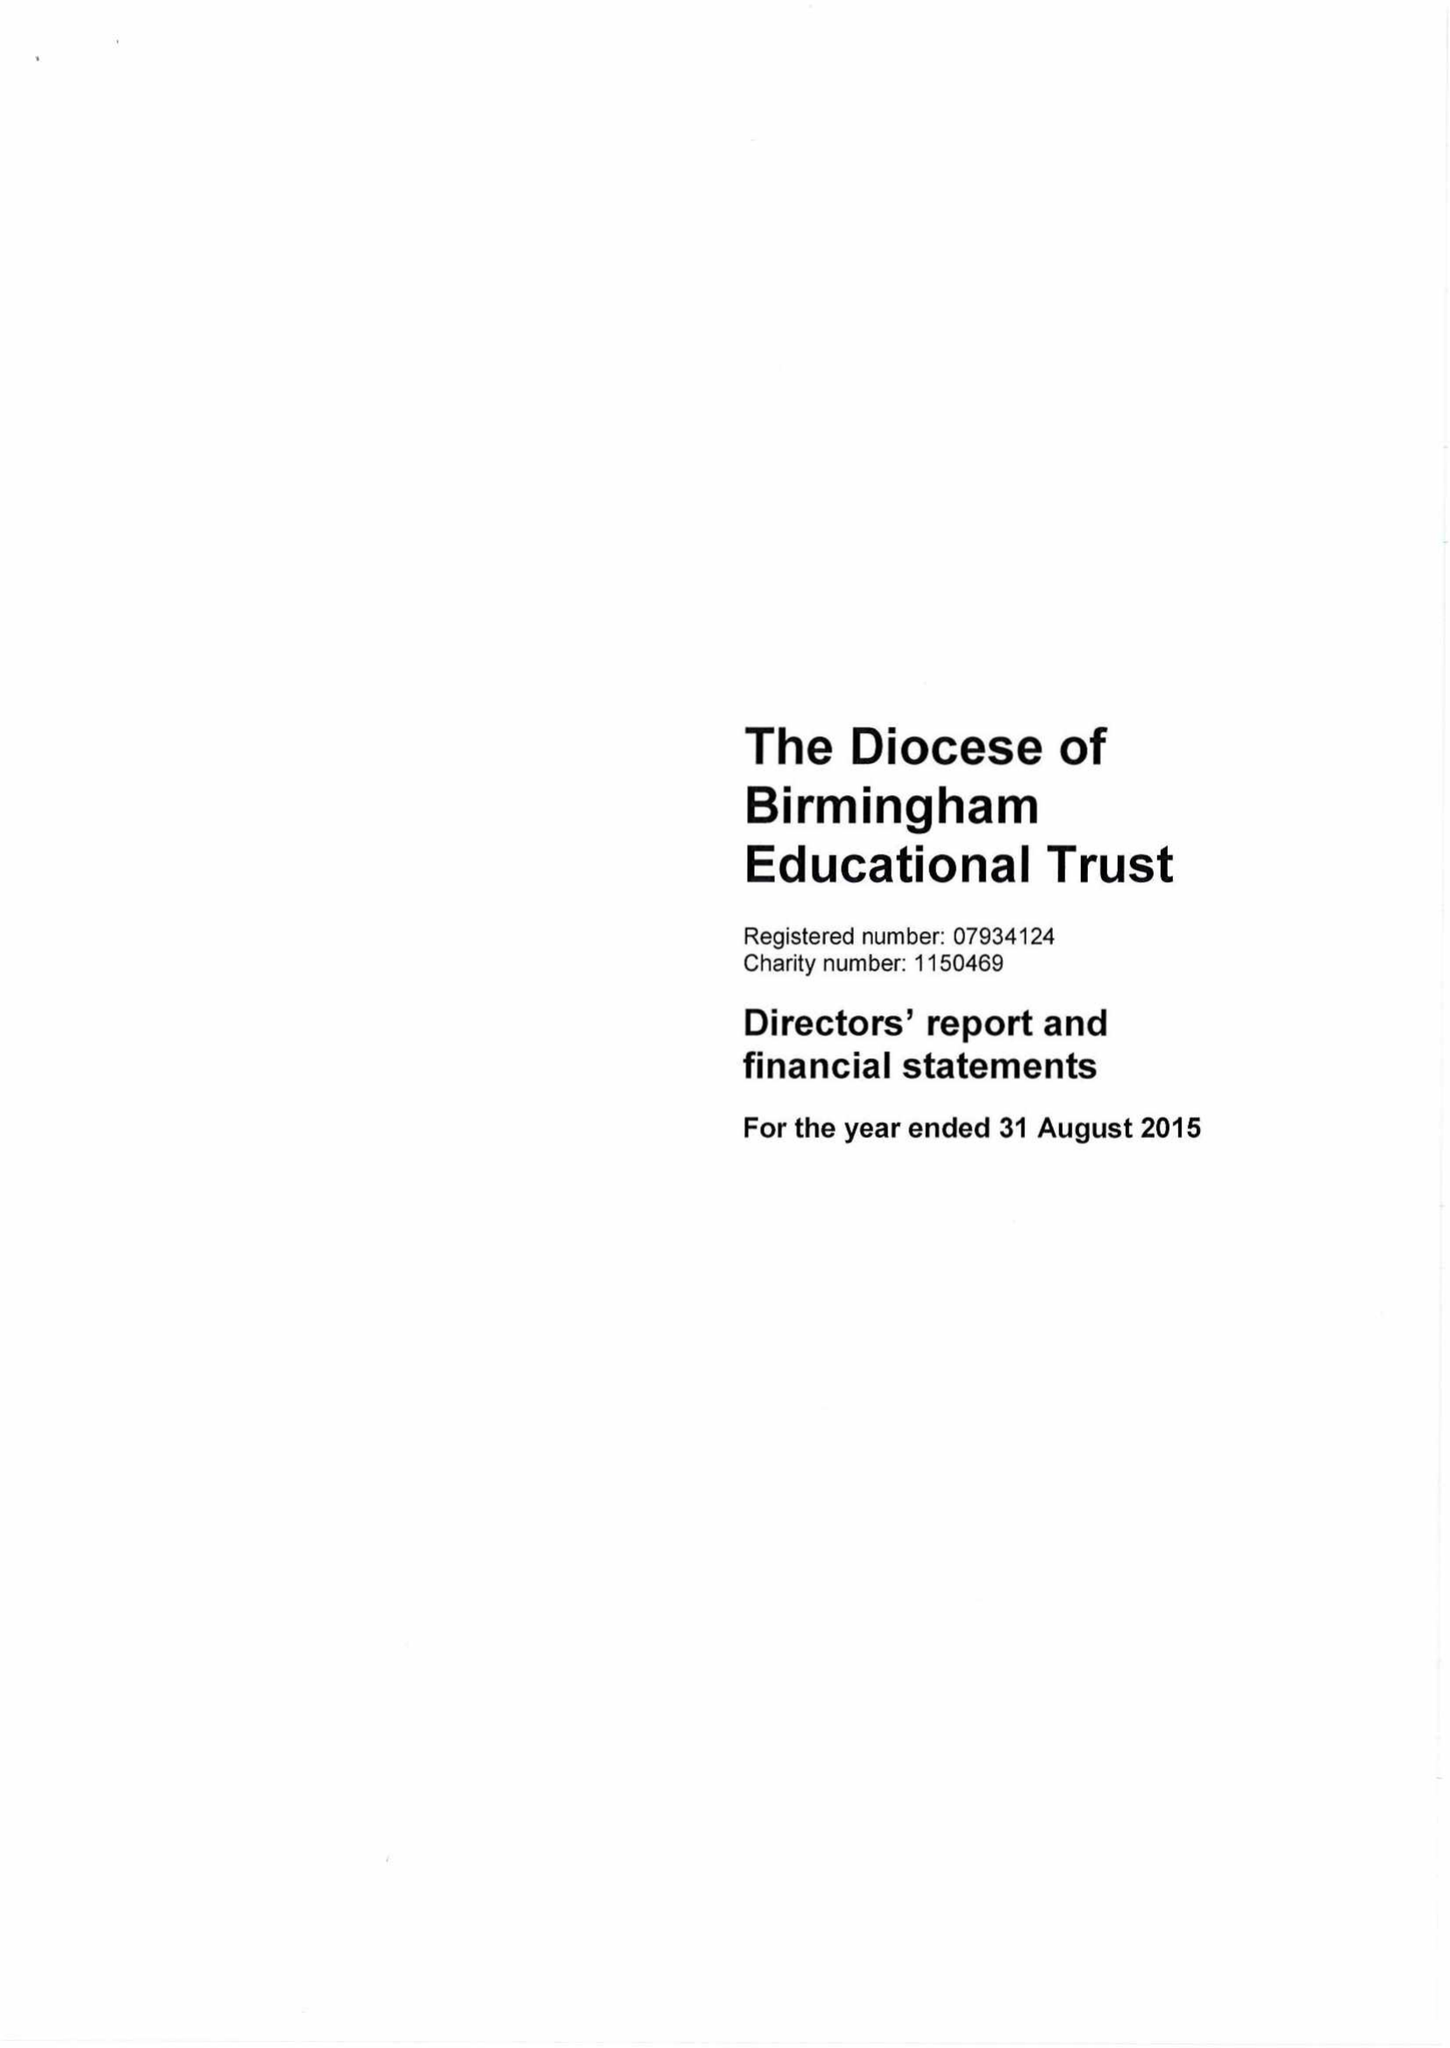What is the value for the address__street_line?
Answer the question using a single word or phrase. 1 COLMORE ROW 